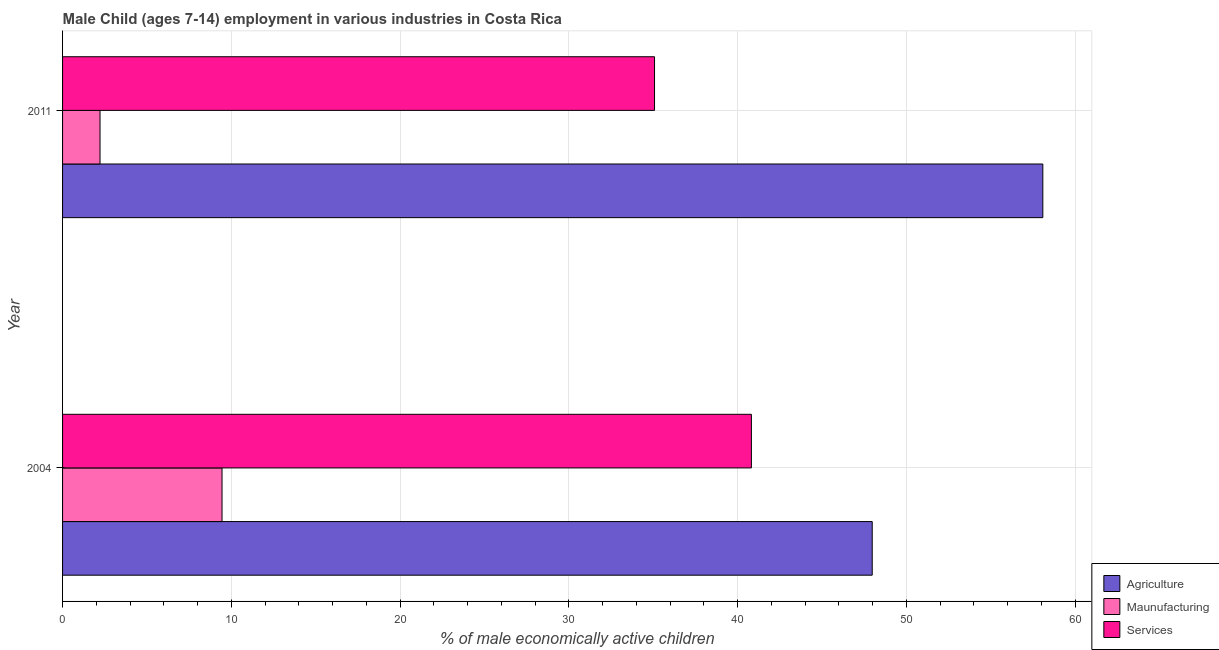How many different coloured bars are there?
Offer a very short reply. 3. Are the number of bars on each tick of the Y-axis equal?
Offer a very short reply. Yes. How many bars are there on the 1st tick from the top?
Provide a short and direct response. 3. What is the percentage of economically active children in agriculture in 2004?
Provide a short and direct response. 47.98. Across all years, what is the maximum percentage of economically active children in manufacturing?
Offer a very short reply. 9.45. Across all years, what is the minimum percentage of economically active children in agriculture?
Give a very brief answer. 47.98. What is the total percentage of economically active children in manufacturing in the graph?
Make the answer very short. 11.67. What is the difference between the percentage of economically active children in agriculture in 2004 and that in 2011?
Provide a succinct answer. -10.11. What is the difference between the percentage of economically active children in services in 2004 and the percentage of economically active children in agriculture in 2011?
Your response must be concise. -17.27. What is the average percentage of economically active children in manufacturing per year?
Provide a short and direct response. 5.83. In the year 2011, what is the difference between the percentage of economically active children in agriculture and percentage of economically active children in services?
Provide a short and direct response. 23.01. In how many years, is the percentage of economically active children in services greater than 16 %?
Your response must be concise. 2. What is the ratio of the percentage of economically active children in manufacturing in 2004 to that in 2011?
Your answer should be very brief. 4.26. What does the 2nd bar from the top in 2004 represents?
Offer a very short reply. Maunufacturing. What does the 3rd bar from the bottom in 2004 represents?
Give a very brief answer. Services. How many years are there in the graph?
Ensure brevity in your answer.  2. What is the difference between two consecutive major ticks on the X-axis?
Give a very brief answer. 10. Does the graph contain any zero values?
Offer a very short reply. No. Where does the legend appear in the graph?
Your answer should be compact. Bottom right. What is the title of the graph?
Provide a short and direct response. Male Child (ages 7-14) employment in various industries in Costa Rica. What is the label or title of the X-axis?
Your answer should be compact. % of male economically active children. What is the label or title of the Y-axis?
Make the answer very short. Year. What is the % of male economically active children of Agriculture in 2004?
Give a very brief answer. 47.98. What is the % of male economically active children of Maunufacturing in 2004?
Your response must be concise. 9.45. What is the % of male economically active children of Services in 2004?
Offer a very short reply. 40.82. What is the % of male economically active children in Agriculture in 2011?
Your answer should be compact. 58.09. What is the % of male economically active children in Maunufacturing in 2011?
Make the answer very short. 2.22. What is the % of male economically active children in Services in 2011?
Give a very brief answer. 35.08. Across all years, what is the maximum % of male economically active children of Agriculture?
Keep it short and to the point. 58.09. Across all years, what is the maximum % of male economically active children of Maunufacturing?
Ensure brevity in your answer.  9.45. Across all years, what is the maximum % of male economically active children in Services?
Offer a terse response. 40.82. Across all years, what is the minimum % of male economically active children of Agriculture?
Your answer should be compact. 47.98. Across all years, what is the minimum % of male economically active children in Maunufacturing?
Give a very brief answer. 2.22. Across all years, what is the minimum % of male economically active children in Services?
Provide a succinct answer. 35.08. What is the total % of male economically active children of Agriculture in the graph?
Make the answer very short. 106.07. What is the total % of male economically active children of Maunufacturing in the graph?
Your answer should be compact. 11.67. What is the total % of male economically active children of Services in the graph?
Your answer should be compact. 75.9. What is the difference between the % of male economically active children of Agriculture in 2004 and that in 2011?
Make the answer very short. -10.11. What is the difference between the % of male economically active children in Maunufacturing in 2004 and that in 2011?
Keep it short and to the point. 7.23. What is the difference between the % of male economically active children in Services in 2004 and that in 2011?
Keep it short and to the point. 5.74. What is the difference between the % of male economically active children of Agriculture in 2004 and the % of male economically active children of Maunufacturing in 2011?
Make the answer very short. 45.76. What is the difference between the % of male economically active children of Maunufacturing in 2004 and the % of male economically active children of Services in 2011?
Keep it short and to the point. -25.63. What is the average % of male economically active children in Agriculture per year?
Make the answer very short. 53.03. What is the average % of male economically active children in Maunufacturing per year?
Provide a succinct answer. 5.83. What is the average % of male economically active children of Services per year?
Your answer should be compact. 37.95. In the year 2004, what is the difference between the % of male economically active children of Agriculture and % of male economically active children of Maunufacturing?
Make the answer very short. 38.53. In the year 2004, what is the difference between the % of male economically active children of Agriculture and % of male economically active children of Services?
Ensure brevity in your answer.  7.16. In the year 2004, what is the difference between the % of male economically active children of Maunufacturing and % of male economically active children of Services?
Keep it short and to the point. -31.37. In the year 2011, what is the difference between the % of male economically active children in Agriculture and % of male economically active children in Maunufacturing?
Offer a terse response. 55.87. In the year 2011, what is the difference between the % of male economically active children in Agriculture and % of male economically active children in Services?
Give a very brief answer. 23.01. In the year 2011, what is the difference between the % of male economically active children in Maunufacturing and % of male economically active children in Services?
Give a very brief answer. -32.86. What is the ratio of the % of male economically active children in Agriculture in 2004 to that in 2011?
Provide a short and direct response. 0.83. What is the ratio of the % of male economically active children in Maunufacturing in 2004 to that in 2011?
Offer a terse response. 4.26. What is the ratio of the % of male economically active children in Services in 2004 to that in 2011?
Your answer should be very brief. 1.16. What is the difference between the highest and the second highest % of male economically active children of Agriculture?
Your answer should be very brief. 10.11. What is the difference between the highest and the second highest % of male economically active children of Maunufacturing?
Provide a succinct answer. 7.23. What is the difference between the highest and the second highest % of male economically active children of Services?
Your answer should be compact. 5.74. What is the difference between the highest and the lowest % of male economically active children of Agriculture?
Give a very brief answer. 10.11. What is the difference between the highest and the lowest % of male economically active children in Maunufacturing?
Your answer should be very brief. 7.23. What is the difference between the highest and the lowest % of male economically active children of Services?
Provide a succinct answer. 5.74. 